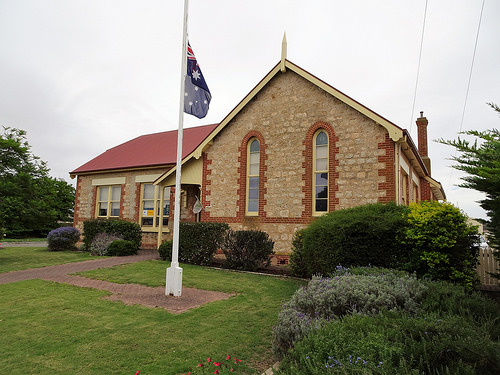<image>
Is the flag to the left of the house? No. The flag is not to the left of the house. From this viewpoint, they have a different horizontal relationship. Where is the pole in relation to the house? Is it next to the house? Yes. The pole is positioned adjacent to the house, located nearby in the same general area. 